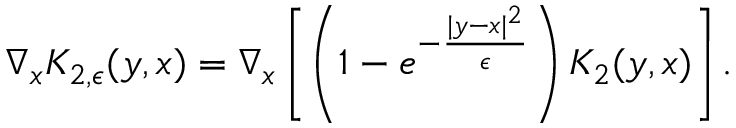<formula> <loc_0><loc_0><loc_500><loc_500>\nabla _ { x } K _ { 2 , \epsilon } ( y , x ) = \nabla _ { x } \left [ \left ( 1 - e ^ { - \frac { | y - x | ^ { 2 } } { \epsilon } } \right ) K _ { 2 } ( y , x ) \right ] .</formula> 